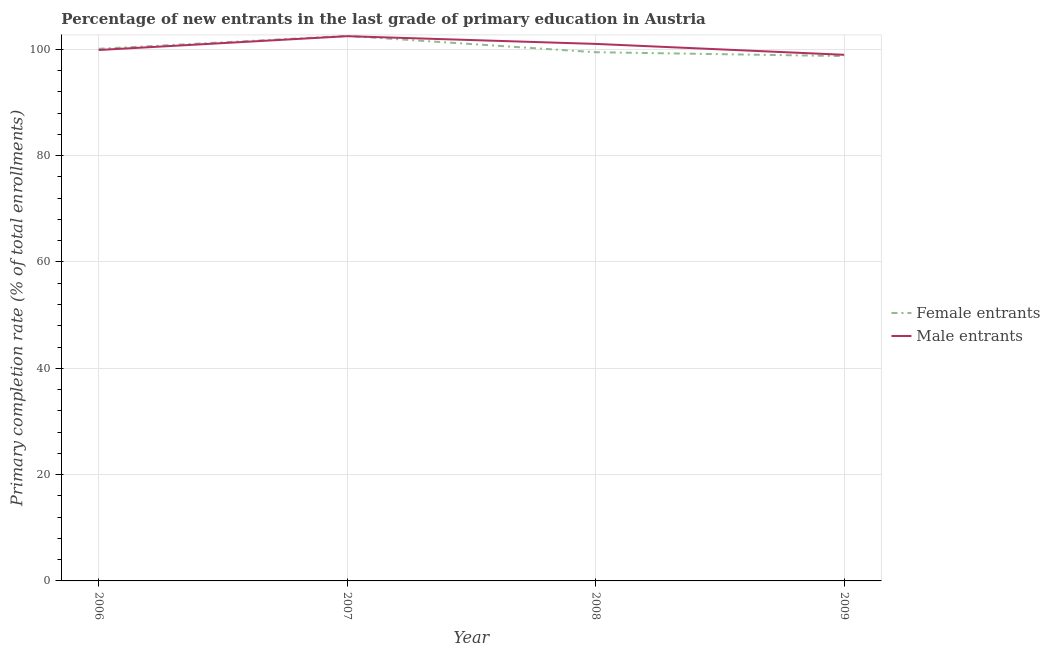How many different coloured lines are there?
Offer a very short reply. 2. Does the line corresponding to primary completion rate of female entrants intersect with the line corresponding to primary completion rate of male entrants?
Make the answer very short. Yes. What is the primary completion rate of male entrants in 2007?
Make the answer very short. 102.47. Across all years, what is the maximum primary completion rate of male entrants?
Provide a short and direct response. 102.47. Across all years, what is the minimum primary completion rate of female entrants?
Your answer should be compact. 98.73. In which year was the primary completion rate of male entrants maximum?
Provide a short and direct response. 2007. In which year was the primary completion rate of female entrants minimum?
Your answer should be compact. 2009. What is the total primary completion rate of female entrants in the graph?
Ensure brevity in your answer.  400.81. What is the difference between the primary completion rate of female entrants in 2006 and that in 2009?
Keep it short and to the point. 1.37. What is the difference between the primary completion rate of female entrants in 2006 and the primary completion rate of male entrants in 2007?
Keep it short and to the point. -2.37. What is the average primary completion rate of male entrants per year?
Keep it short and to the point. 100.59. In the year 2008, what is the difference between the primary completion rate of female entrants and primary completion rate of male entrants?
Your answer should be very brief. -1.56. What is the ratio of the primary completion rate of male entrants in 2006 to that in 2008?
Provide a succinct answer. 0.99. Is the primary completion rate of female entrants in 2006 less than that in 2007?
Offer a very short reply. Yes. Is the difference between the primary completion rate of female entrants in 2007 and 2008 greater than the difference between the primary completion rate of male entrants in 2007 and 2008?
Provide a short and direct response. Yes. What is the difference between the highest and the second highest primary completion rate of male entrants?
Provide a succinct answer. 1.45. What is the difference between the highest and the lowest primary completion rate of female entrants?
Keep it short and to the point. 3.8. Does the primary completion rate of female entrants monotonically increase over the years?
Your answer should be very brief. No. What is the difference between two consecutive major ticks on the Y-axis?
Your answer should be compact. 20. Are the values on the major ticks of Y-axis written in scientific E-notation?
Give a very brief answer. No. Does the graph contain any zero values?
Provide a succinct answer. No. Does the graph contain grids?
Provide a succinct answer. Yes. How many legend labels are there?
Make the answer very short. 2. How are the legend labels stacked?
Make the answer very short. Vertical. What is the title of the graph?
Offer a very short reply. Percentage of new entrants in the last grade of primary education in Austria. What is the label or title of the Y-axis?
Ensure brevity in your answer.  Primary completion rate (% of total enrollments). What is the Primary completion rate (% of total enrollments) of Female entrants in 2006?
Offer a terse response. 100.1. What is the Primary completion rate (% of total enrollments) of Male entrants in 2006?
Provide a succinct answer. 99.87. What is the Primary completion rate (% of total enrollments) in Female entrants in 2007?
Offer a terse response. 102.53. What is the Primary completion rate (% of total enrollments) in Male entrants in 2007?
Ensure brevity in your answer.  102.47. What is the Primary completion rate (% of total enrollments) of Female entrants in 2008?
Offer a very short reply. 99.46. What is the Primary completion rate (% of total enrollments) of Male entrants in 2008?
Provide a short and direct response. 101.02. What is the Primary completion rate (% of total enrollments) of Female entrants in 2009?
Your answer should be compact. 98.73. What is the Primary completion rate (% of total enrollments) of Male entrants in 2009?
Your answer should be compact. 98.97. Across all years, what is the maximum Primary completion rate (% of total enrollments) of Female entrants?
Offer a terse response. 102.53. Across all years, what is the maximum Primary completion rate (% of total enrollments) of Male entrants?
Provide a succinct answer. 102.47. Across all years, what is the minimum Primary completion rate (% of total enrollments) of Female entrants?
Ensure brevity in your answer.  98.73. Across all years, what is the minimum Primary completion rate (% of total enrollments) in Male entrants?
Keep it short and to the point. 98.97. What is the total Primary completion rate (% of total enrollments) of Female entrants in the graph?
Your answer should be compact. 400.81. What is the total Primary completion rate (% of total enrollments) of Male entrants in the graph?
Keep it short and to the point. 402.34. What is the difference between the Primary completion rate (% of total enrollments) in Female entrants in 2006 and that in 2007?
Your response must be concise. -2.43. What is the difference between the Primary completion rate (% of total enrollments) in Male entrants in 2006 and that in 2007?
Provide a short and direct response. -2.6. What is the difference between the Primary completion rate (% of total enrollments) of Female entrants in 2006 and that in 2008?
Offer a very short reply. 0.64. What is the difference between the Primary completion rate (% of total enrollments) in Male entrants in 2006 and that in 2008?
Offer a very short reply. -1.15. What is the difference between the Primary completion rate (% of total enrollments) in Female entrants in 2006 and that in 2009?
Provide a short and direct response. 1.37. What is the difference between the Primary completion rate (% of total enrollments) in Male entrants in 2006 and that in 2009?
Your answer should be very brief. 0.9. What is the difference between the Primary completion rate (% of total enrollments) in Female entrants in 2007 and that in 2008?
Provide a succinct answer. 3.07. What is the difference between the Primary completion rate (% of total enrollments) of Male entrants in 2007 and that in 2008?
Offer a very short reply. 1.45. What is the difference between the Primary completion rate (% of total enrollments) of Female entrants in 2007 and that in 2009?
Offer a terse response. 3.8. What is the difference between the Primary completion rate (% of total enrollments) in Male entrants in 2007 and that in 2009?
Keep it short and to the point. 3.5. What is the difference between the Primary completion rate (% of total enrollments) of Female entrants in 2008 and that in 2009?
Your answer should be very brief. 0.73. What is the difference between the Primary completion rate (% of total enrollments) of Male entrants in 2008 and that in 2009?
Offer a very short reply. 2.05. What is the difference between the Primary completion rate (% of total enrollments) in Female entrants in 2006 and the Primary completion rate (% of total enrollments) in Male entrants in 2007?
Give a very brief answer. -2.37. What is the difference between the Primary completion rate (% of total enrollments) of Female entrants in 2006 and the Primary completion rate (% of total enrollments) of Male entrants in 2008?
Your answer should be compact. -0.92. What is the difference between the Primary completion rate (% of total enrollments) of Female entrants in 2006 and the Primary completion rate (% of total enrollments) of Male entrants in 2009?
Offer a very short reply. 1.13. What is the difference between the Primary completion rate (% of total enrollments) in Female entrants in 2007 and the Primary completion rate (% of total enrollments) in Male entrants in 2008?
Give a very brief answer. 1.51. What is the difference between the Primary completion rate (% of total enrollments) in Female entrants in 2007 and the Primary completion rate (% of total enrollments) in Male entrants in 2009?
Make the answer very short. 3.56. What is the difference between the Primary completion rate (% of total enrollments) of Female entrants in 2008 and the Primary completion rate (% of total enrollments) of Male entrants in 2009?
Provide a short and direct response. 0.48. What is the average Primary completion rate (% of total enrollments) of Female entrants per year?
Offer a very short reply. 100.2. What is the average Primary completion rate (% of total enrollments) of Male entrants per year?
Make the answer very short. 100.58. In the year 2006, what is the difference between the Primary completion rate (% of total enrollments) of Female entrants and Primary completion rate (% of total enrollments) of Male entrants?
Your answer should be very brief. 0.23. In the year 2007, what is the difference between the Primary completion rate (% of total enrollments) of Female entrants and Primary completion rate (% of total enrollments) of Male entrants?
Ensure brevity in your answer.  0.06. In the year 2008, what is the difference between the Primary completion rate (% of total enrollments) of Female entrants and Primary completion rate (% of total enrollments) of Male entrants?
Make the answer very short. -1.56. In the year 2009, what is the difference between the Primary completion rate (% of total enrollments) of Female entrants and Primary completion rate (% of total enrollments) of Male entrants?
Make the answer very short. -0.25. What is the ratio of the Primary completion rate (% of total enrollments) of Female entrants in 2006 to that in 2007?
Offer a very short reply. 0.98. What is the ratio of the Primary completion rate (% of total enrollments) in Male entrants in 2006 to that in 2007?
Your response must be concise. 0.97. What is the ratio of the Primary completion rate (% of total enrollments) of Female entrants in 2006 to that in 2008?
Your response must be concise. 1.01. What is the ratio of the Primary completion rate (% of total enrollments) in Male entrants in 2006 to that in 2008?
Your answer should be very brief. 0.99. What is the ratio of the Primary completion rate (% of total enrollments) in Female entrants in 2006 to that in 2009?
Your response must be concise. 1.01. What is the ratio of the Primary completion rate (% of total enrollments) of Male entrants in 2006 to that in 2009?
Ensure brevity in your answer.  1.01. What is the ratio of the Primary completion rate (% of total enrollments) in Female entrants in 2007 to that in 2008?
Keep it short and to the point. 1.03. What is the ratio of the Primary completion rate (% of total enrollments) of Male entrants in 2007 to that in 2008?
Provide a short and direct response. 1.01. What is the ratio of the Primary completion rate (% of total enrollments) in Female entrants in 2007 to that in 2009?
Give a very brief answer. 1.04. What is the ratio of the Primary completion rate (% of total enrollments) in Male entrants in 2007 to that in 2009?
Provide a short and direct response. 1.04. What is the ratio of the Primary completion rate (% of total enrollments) in Female entrants in 2008 to that in 2009?
Make the answer very short. 1.01. What is the ratio of the Primary completion rate (% of total enrollments) of Male entrants in 2008 to that in 2009?
Keep it short and to the point. 1.02. What is the difference between the highest and the second highest Primary completion rate (% of total enrollments) in Female entrants?
Give a very brief answer. 2.43. What is the difference between the highest and the second highest Primary completion rate (% of total enrollments) in Male entrants?
Make the answer very short. 1.45. What is the difference between the highest and the lowest Primary completion rate (% of total enrollments) in Female entrants?
Provide a short and direct response. 3.8. What is the difference between the highest and the lowest Primary completion rate (% of total enrollments) of Male entrants?
Your answer should be very brief. 3.5. 